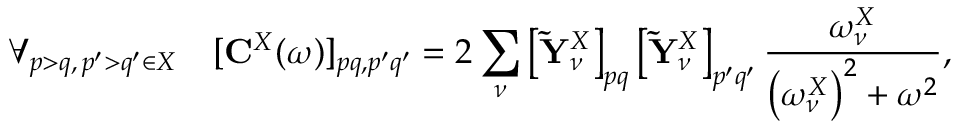<formula> <loc_0><loc_0><loc_500><loc_500>\forall _ { p > q , \, p ^ { \prime } > q ^ { \prime } \in X } \quad [ { C } ^ { X } ( \omega ) ] _ { p q , p ^ { \prime } q ^ { \prime } } = 2 \sum _ { \nu } \left [ \tilde { Y } _ { \nu } ^ { X } \right ] _ { p q } \left [ \tilde { Y } _ { \nu } ^ { X } \right ] _ { p ^ { \prime } q ^ { \prime } } \frac { \omega _ { \nu } ^ { X } } { \left ( \omega _ { \nu } ^ { X } \right ) ^ { 2 } + \omega ^ { 2 } } ,</formula> 